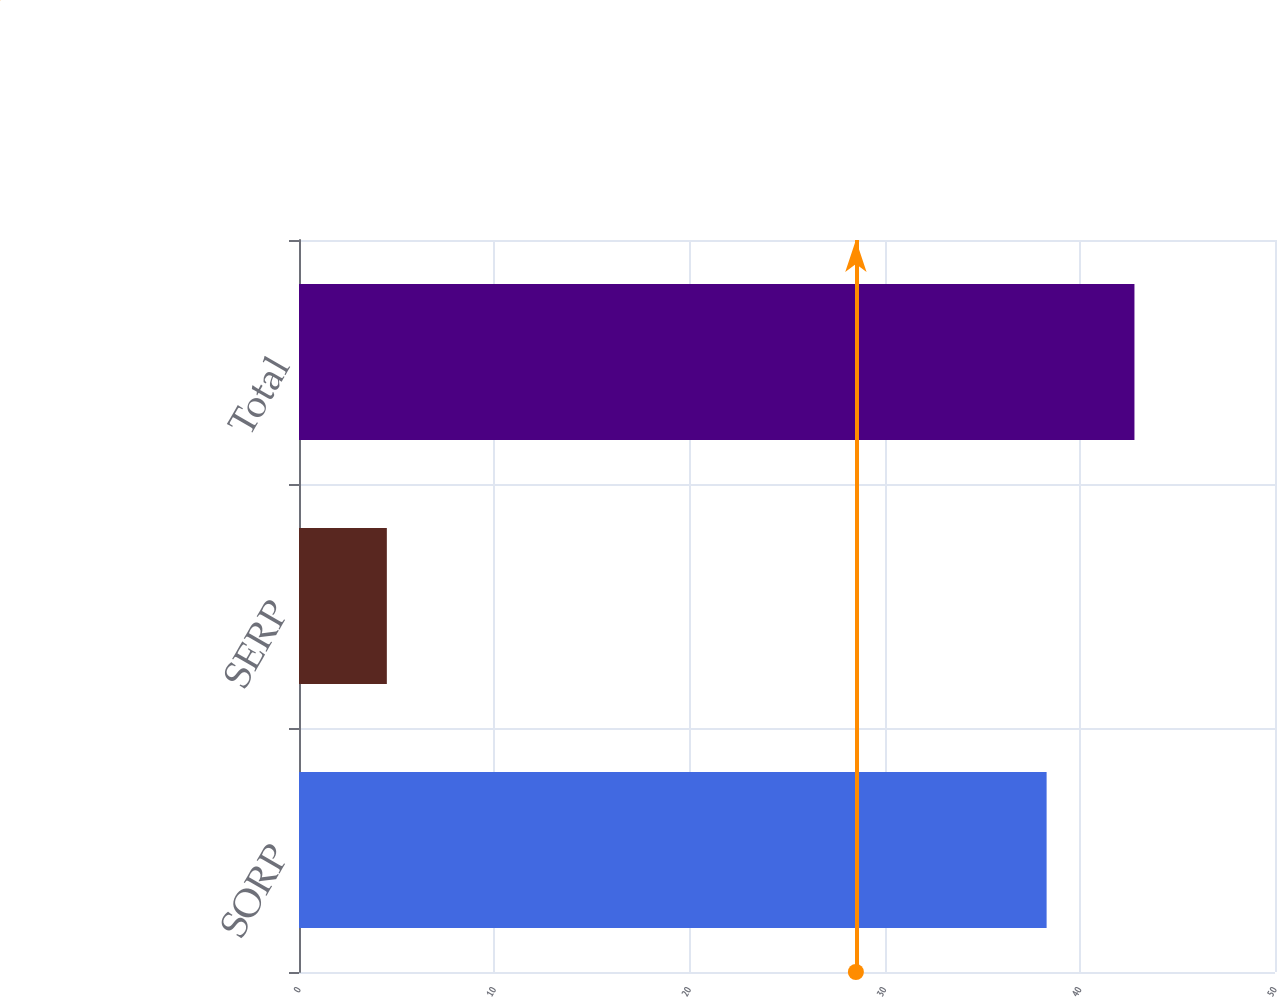Convert chart. <chart><loc_0><loc_0><loc_500><loc_500><bar_chart><fcel>SORP<fcel>SERP<fcel>Total<nl><fcel>38.3<fcel>4.5<fcel>42.8<nl></chart> 